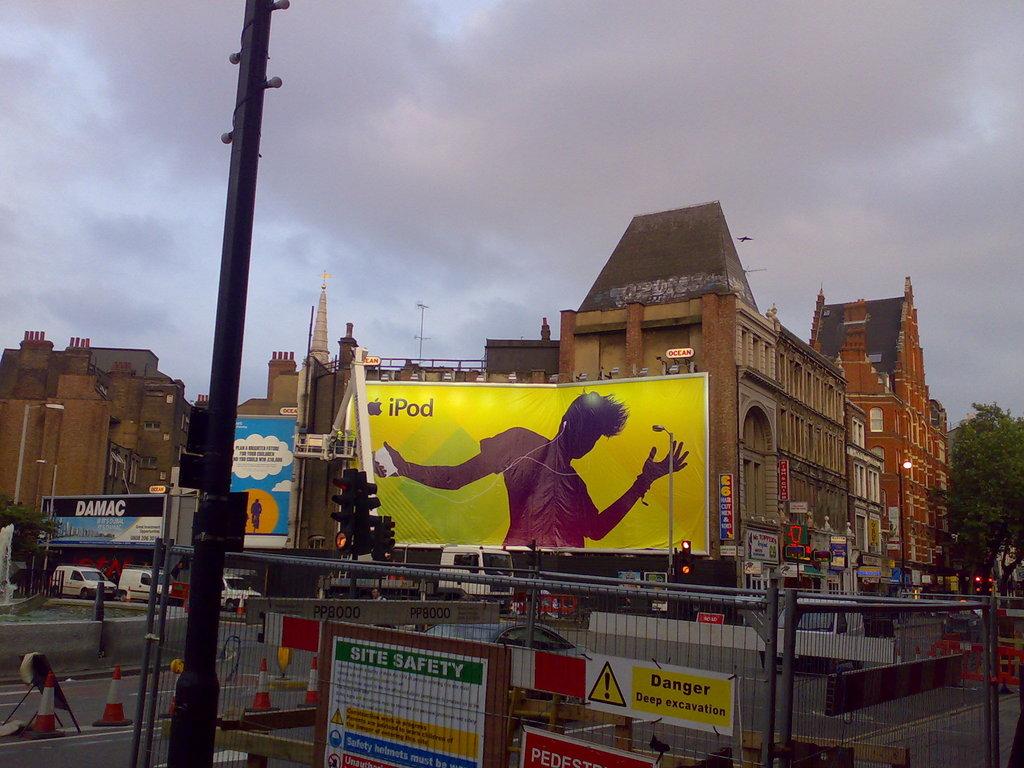What is the warning word on the sign in the left corner of the fence?
Make the answer very short. Danger. 